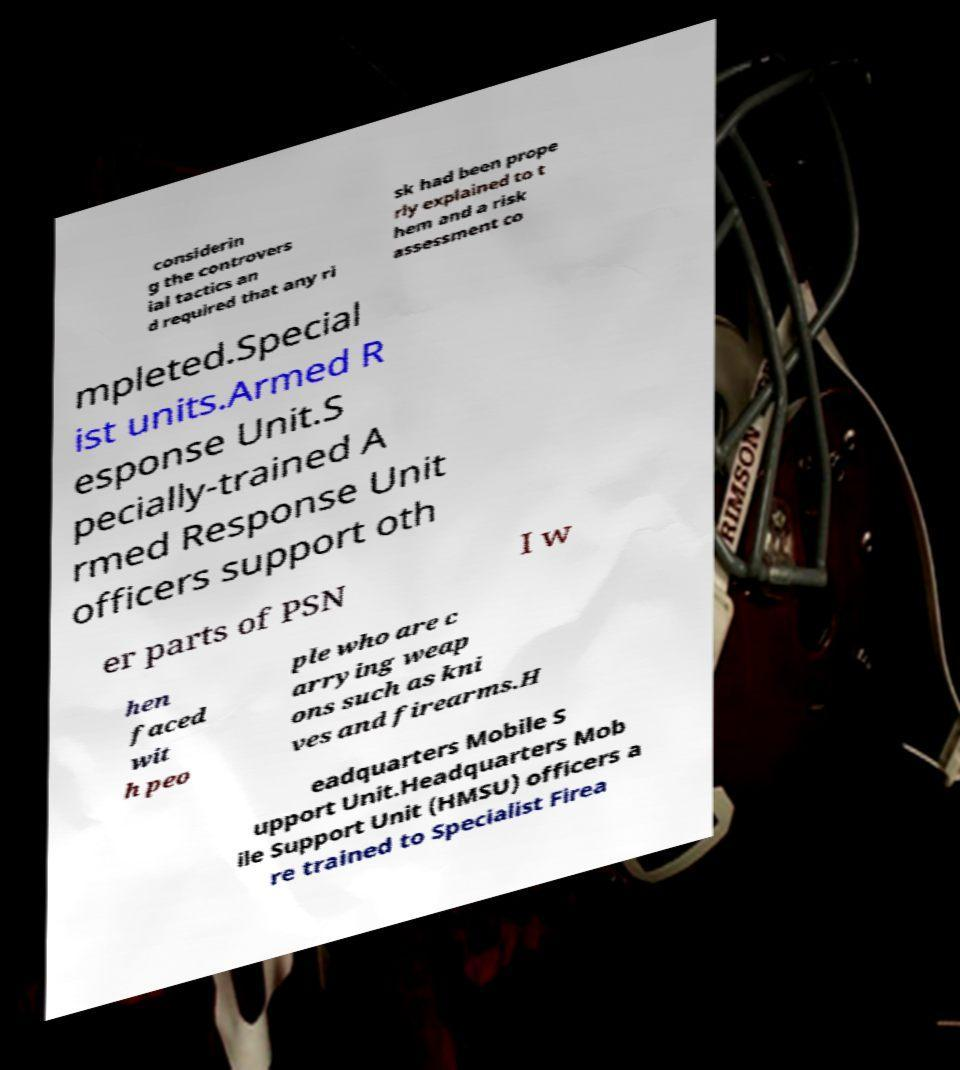Please identify and transcribe the text found in this image. considerin g the controvers ial tactics an d required that any ri sk had been prope rly explained to t hem and a risk assessment co mpleted.Special ist units.Armed R esponse Unit.S pecially-trained A rmed Response Unit officers support oth er parts of PSN I w hen faced wit h peo ple who are c arrying weap ons such as kni ves and firearms.H eadquarters Mobile S upport Unit.Headquarters Mob ile Support Unit (HMSU) officers a re trained to Specialist Firea 